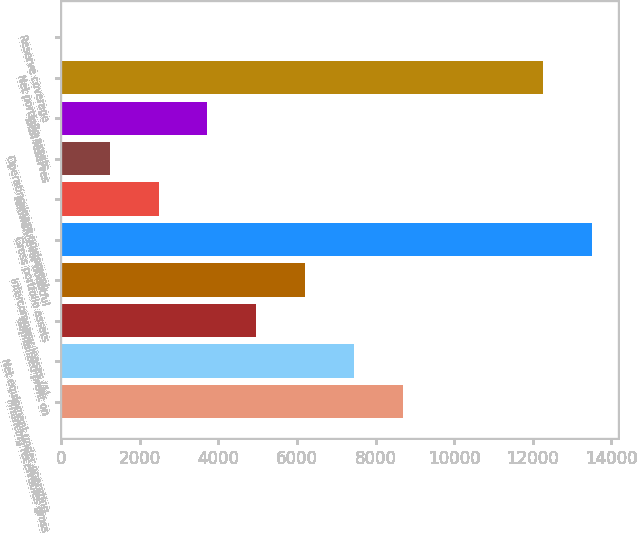Convert chart to OTSL. <chart><loc_0><loc_0><loc_500><loc_500><bar_chart><fcel>Financing receivables gross<fcel>Net equipment under operating<fcel>Capitalized profit on<fcel>Intercompany leases (1)<fcel>Gross portfolio assets<fcel>Allowance for doubtful<fcel>Operating lease equipment<fcel>Total reserves<fcel>Net portfolio assets<fcel>Reserve coverage<nl><fcel>8689.46<fcel>7448.28<fcel>4965.92<fcel>6207.1<fcel>13501.2<fcel>2483.56<fcel>1242.38<fcel>3724.74<fcel>12260<fcel>1.2<nl></chart> 